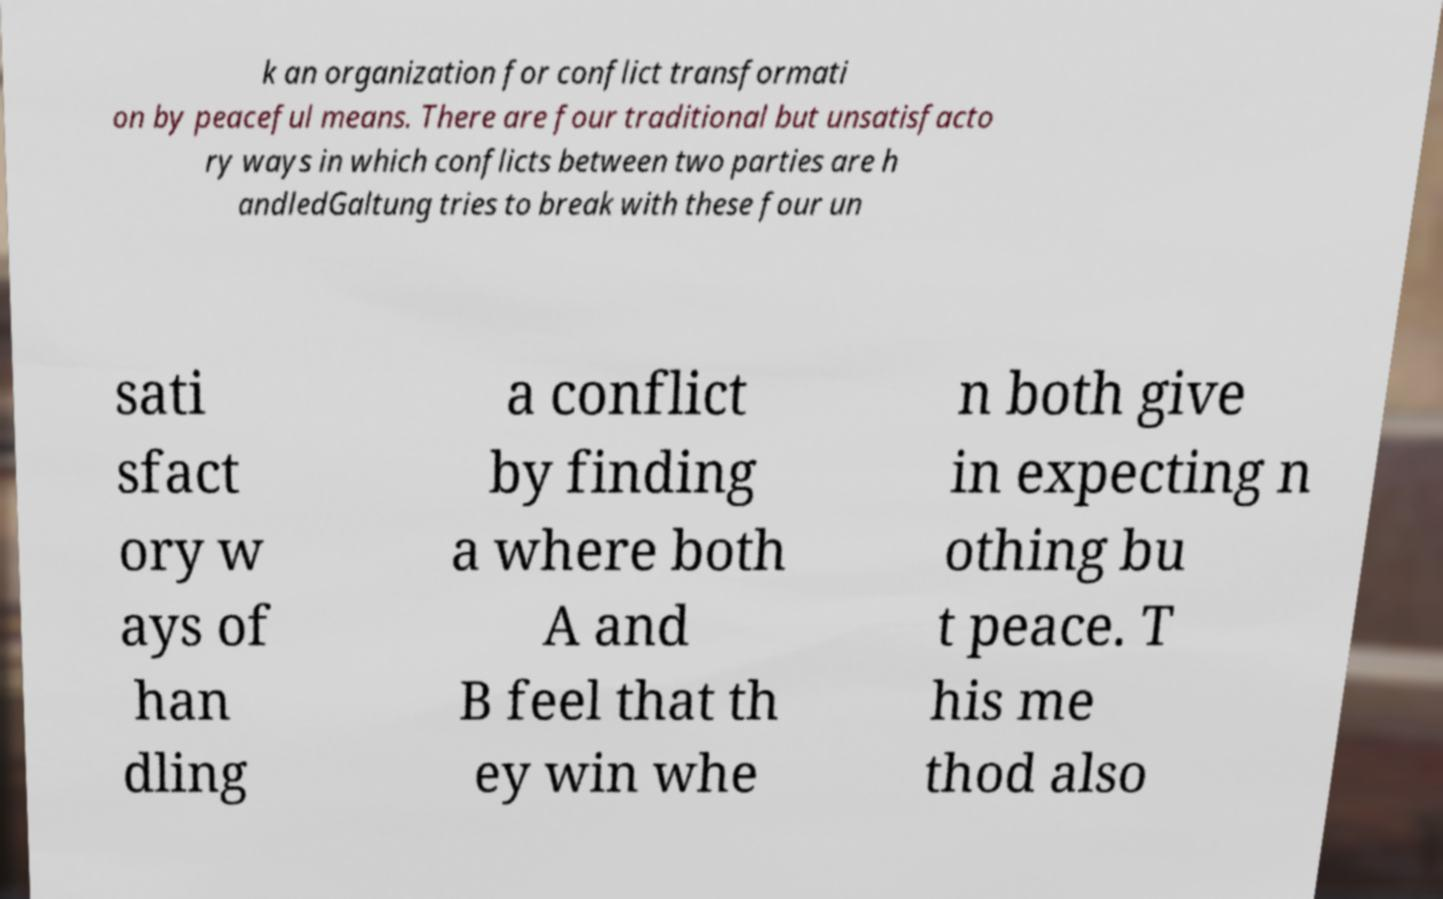There's text embedded in this image that I need extracted. Can you transcribe it verbatim? k an organization for conflict transformati on by peaceful means. There are four traditional but unsatisfacto ry ways in which conflicts between two parties are h andledGaltung tries to break with these four un sati sfact ory w ays of han dling a conflict by finding a where both A and B feel that th ey win whe n both give in expecting n othing bu t peace. T his me thod also 